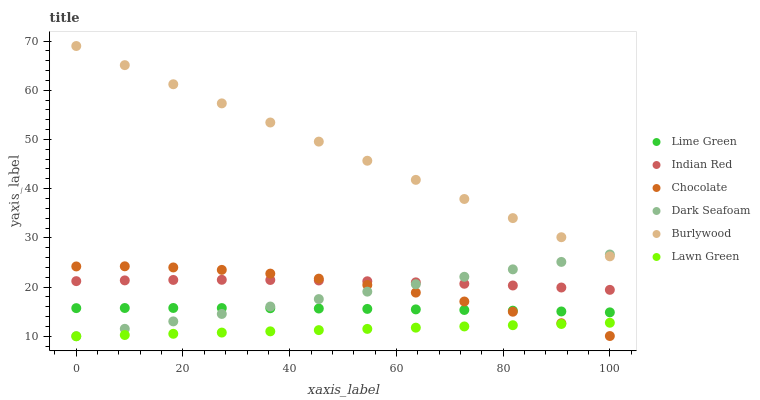Does Lawn Green have the minimum area under the curve?
Answer yes or no. Yes. Does Burlywood have the maximum area under the curve?
Answer yes or no. Yes. Does Chocolate have the minimum area under the curve?
Answer yes or no. No. Does Chocolate have the maximum area under the curve?
Answer yes or no. No. Is Lawn Green the smoothest?
Answer yes or no. Yes. Is Chocolate the roughest?
Answer yes or no. Yes. Is Burlywood the smoothest?
Answer yes or no. No. Is Burlywood the roughest?
Answer yes or no. No. Does Lawn Green have the lowest value?
Answer yes or no. Yes. Does Chocolate have the lowest value?
Answer yes or no. No. Does Burlywood have the highest value?
Answer yes or no. Yes. Does Chocolate have the highest value?
Answer yes or no. No. Is Lawn Green less than Burlywood?
Answer yes or no. Yes. Is Burlywood greater than Indian Red?
Answer yes or no. Yes. Does Chocolate intersect Indian Red?
Answer yes or no. Yes. Is Chocolate less than Indian Red?
Answer yes or no. No. Is Chocolate greater than Indian Red?
Answer yes or no. No. Does Lawn Green intersect Burlywood?
Answer yes or no. No. 